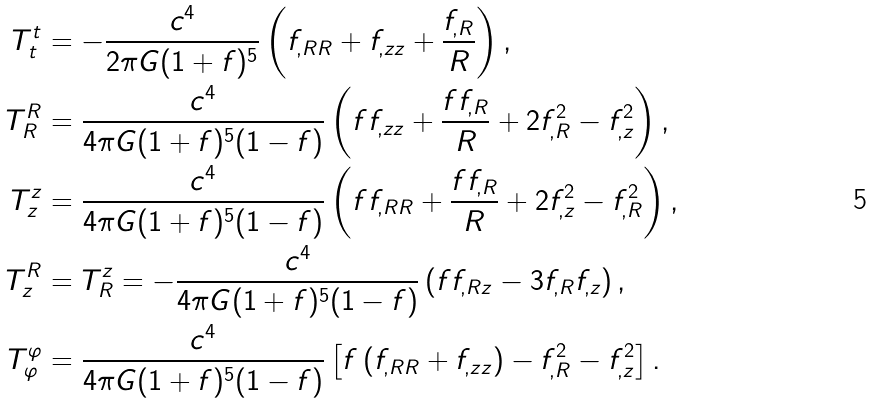Convert formula to latex. <formula><loc_0><loc_0><loc_500><loc_500>T ^ { t } _ { t } & = - \frac { c ^ { 4 } } { 2 \pi G ( 1 + f ) ^ { 5 } } \left ( f _ { , R R } + f _ { , z z } + \frac { f _ { , R } } { R } \right ) , \\ T ^ { R } _ { R } & = \frac { c ^ { 4 } } { 4 \pi G ( 1 + f ) ^ { 5 } ( 1 - f ) } \left ( f f _ { , z z } + \frac { f f _ { , R } } { R } + 2 f _ { , R } ^ { 2 } - f _ { , z } ^ { 2 } \right ) , \\ T ^ { z } _ { z } & = \frac { c ^ { 4 } } { 4 \pi G ( 1 + f ) ^ { 5 } ( 1 - f ) } \left ( f f _ { , R R } + \frac { f f _ { , R } } { R } + 2 f _ { , z } ^ { 2 } - f _ { , R } ^ { 2 } \right ) , \\ T ^ { R } _ { z } & = T ^ { z } _ { R } = - \frac { c ^ { 4 } } { 4 \pi G ( 1 + f ) ^ { 5 } ( 1 - f ) } \left ( f f _ { , R z } - 3 f _ { , R } f _ { , z } \right ) , \\ T ^ { \varphi } _ { \varphi } & = \frac { c ^ { 4 } } { 4 \pi G ( 1 + f ) ^ { 5 } ( 1 - f ) } \left [ f \left ( f _ { , R R } + f _ { , z z } \right ) - f _ { , R } ^ { 2 } - f _ { , z } ^ { 2 } \right ] .</formula> 